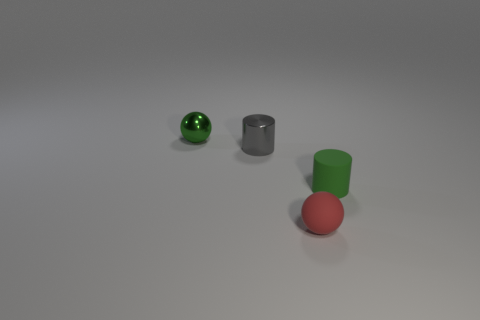How many things are tiny balls to the left of the shiny cylinder or tiny green cylinders?
Offer a very short reply. 2. Do the green object in front of the gray shiny thing and the small gray object have the same material?
Provide a succinct answer. No. Does the small red thing have the same shape as the small green shiny object?
Give a very brief answer. Yes. How many red rubber spheres are to the left of the rubber object that is behind the tiny rubber ball?
Provide a succinct answer. 1. There is a small green object that is the same shape as the tiny red rubber thing; what material is it?
Provide a succinct answer. Metal. Do the sphere that is behind the small green matte object and the rubber cylinder have the same color?
Provide a succinct answer. Yes. Is the small green sphere made of the same material as the small cylinder on the left side of the tiny rubber cylinder?
Make the answer very short. Yes. What shape is the small metal thing that is on the right side of the shiny sphere?
Offer a terse response. Cylinder. How many other things are made of the same material as the green cylinder?
Keep it short and to the point. 1. The red rubber sphere is what size?
Keep it short and to the point. Small. 